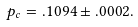Convert formula to latex. <formula><loc_0><loc_0><loc_500><loc_500>p _ { c } = . 1 0 9 4 \pm . 0 0 0 2 .</formula> 